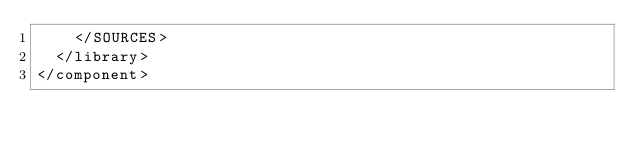<code> <loc_0><loc_0><loc_500><loc_500><_XML_>    </SOURCES>
  </library>
</component></code> 